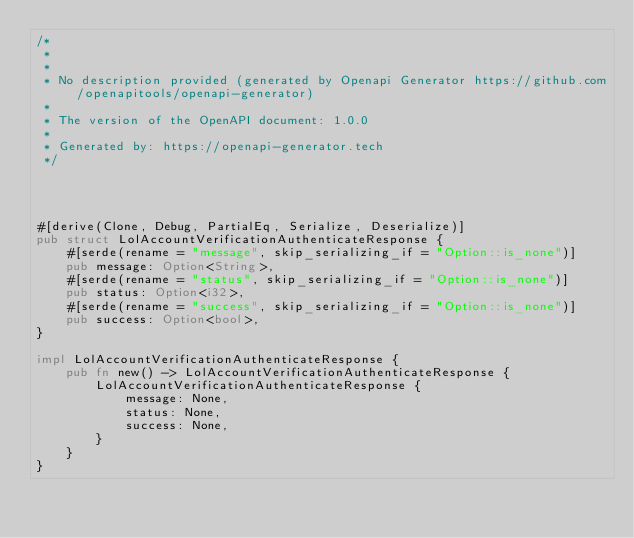<code> <loc_0><loc_0><loc_500><loc_500><_Rust_>/*
 * 
 *
 * No description provided (generated by Openapi Generator https://github.com/openapitools/openapi-generator)
 *
 * The version of the OpenAPI document: 1.0.0
 * 
 * Generated by: https://openapi-generator.tech
 */




#[derive(Clone, Debug, PartialEq, Serialize, Deserialize)]
pub struct LolAccountVerificationAuthenticateResponse {
    #[serde(rename = "message", skip_serializing_if = "Option::is_none")]
    pub message: Option<String>,
    #[serde(rename = "status", skip_serializing_if = "Option::is_none")]
    pub status: Option<i32>,
    #[serde(rename = "success", skip_serializing_if = "Option::is_none")]
    pub success: Option<bool>,
}

impl LolAccountVerificationAuthenticateResponse {
    pub fn new() -> LolAccountVerificationAuthenticateResponse {
        LolAccountVerificationAuthenticateResponse {
            message: None,
            status: None,
            success: None,
        }
    }
}


</code> 